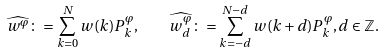<formula> <loc_0><loc_0><loc_500><loc_500>\widehat { w ^ { \varphi } } \colon = \sum _ { k = 0 } ^ { N } w ( k ) P _ { k } ^ { \varphi } , \quad \widehat { w _ { d } ^ { \varphi } } \colon = \sum _ { k = - d } ^ { N - d } w ( k + d ) P _ { k } ^ { \varphi } , d \in \mathbb { Z } .</formula> 